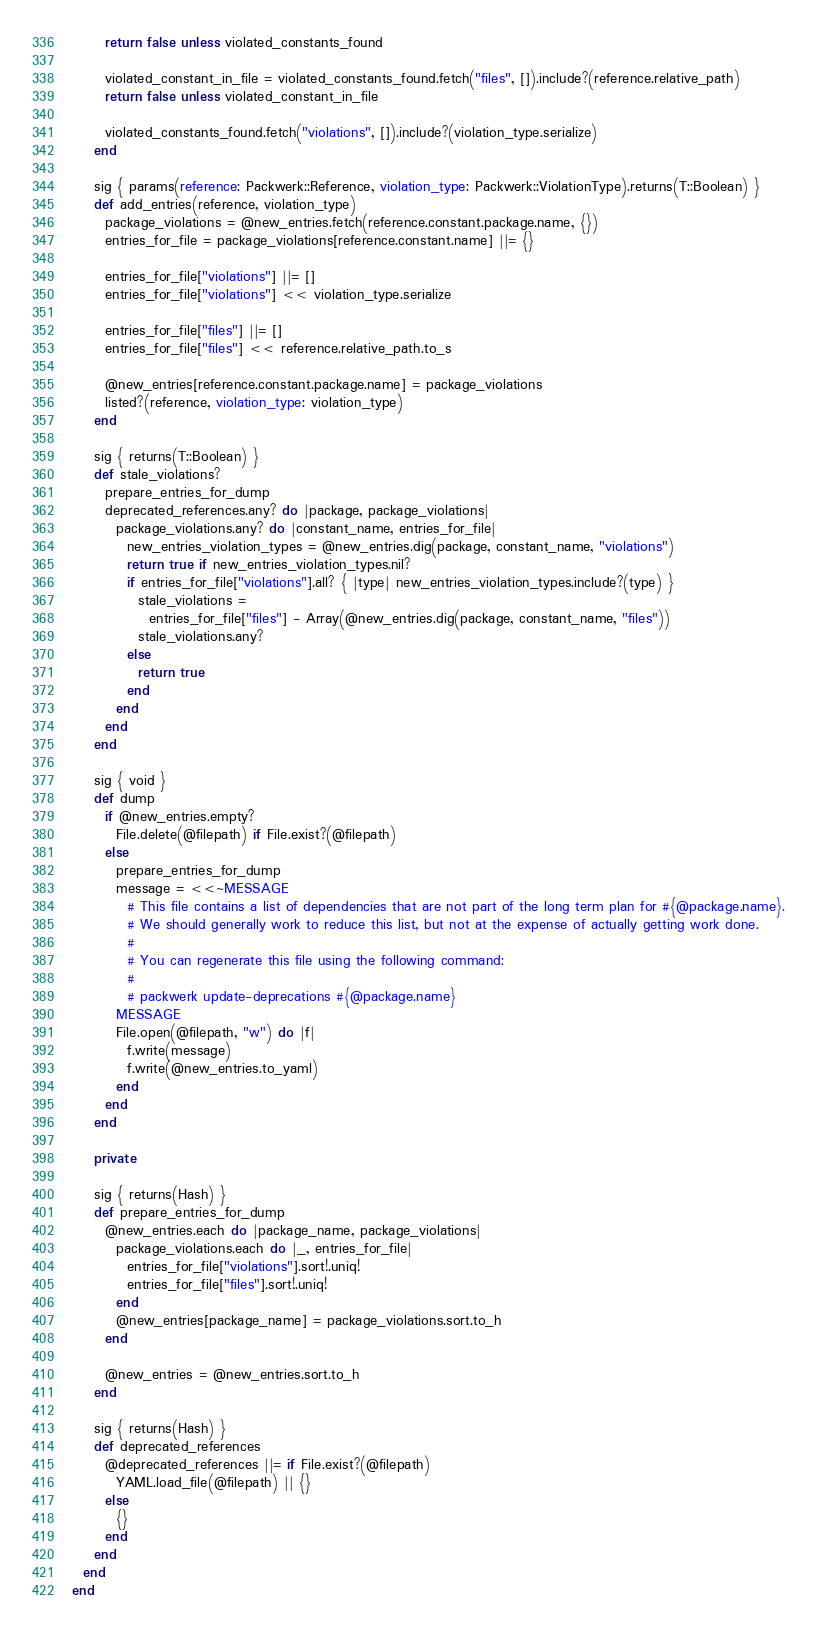<code> <loc_0><loc_0><loc_500><loc_500><_Ruby_>      return false unless violated_constants_found

      violated_constant_in_file = violated_constants_found.fetch("files", []).include?(reference.relative_path)
      return false unless violated_constant_in_file

      violated_constants_found.fetch("violations", []).include?(violation_type.serialize)
    end

    sig { params(reference: Packwerk::Reference, violation_type: Packwerk::ViolationType).returns(T::Boolean) }
    def add_entries(reference, violation_type)
      package_violations = @new_entries.fetch(reference.constant.package.name, {})
      entries_for_file = package_violations[reference.constant.name] ||= {}

      entries_for_file["violations"] ||= []
      entries_for_file["violations"] << violation_type.serialize

      entries_for_file["files"] ||= []
      entries_for_file["files"] << reference.relative_path.to_s

      @new_entries[reference.constant.package.name] = package_violations
      listed?(reference, violation_type: violation_type)
    end

    sig { returns(T::Boolean) }
    def stale_violations?
      prepare_entries_for_dump
      deprecated_references.any? do |package, package_violations|
        package_violations.any? do |constant_name, entries_for_file|
          new_entries_violation_types = @new_entries.dig(package, constant_name, "violations")
          return true if new_entries_violation_types.nil?
          if entries_for_file["violations"].all? { |type| new_entries_violation_types.include?(type) }
            stale_violations =
              entries_for_file["files"] - Array(@new_entries.dig(package, constant_name, "files"))
            stale_violations.any?
          else
            return true
          end
        end
      end
    end

    sig { void }
    def dump
      if @new_entries.empty?
        File.delete(@filepath) if File.exist?(@filepath)
      else
        prepare_entries_for_dump
        message = <<~MESSAGE
          # This file contains a list of dependencies that are not part of the long term plan for #{@package.name}.
          # We should generally work to reduce this list, but not at the expense of actually getting work done.
          #
          # You can regenerate this file using the following command:
          #
          # packwerk update-deprecations #{@package.name}
        MESSAGE
        File.open(@filepath, "w") do |f|
          f.write(message)
          f.write(@new_entries.to_yaml)
        end
      end
    end

    private

    sig { returns(Hash) }
    def prepare_entries_for_dump
      @new_entries.each do |package_name, package_violations|
        package_violations.each do |_, entries_for_file|
          entries_for_file["violations"].sort!.uniq!
          entries_for_file["files"].sort!.uniq!
        end
        @new_entries[package_name] = package_violations.sort.to_h
      end

      @new_entries = @new_entries.sort.to_h
    end

    sig { returns(Hash) }
    def deprecated_references
      @deprecated_references ||= if File.exist?(@filepath)
        YAML.load_file(@filepath) || {}
      else
        {}
      end
    end
  end
end
</code> 